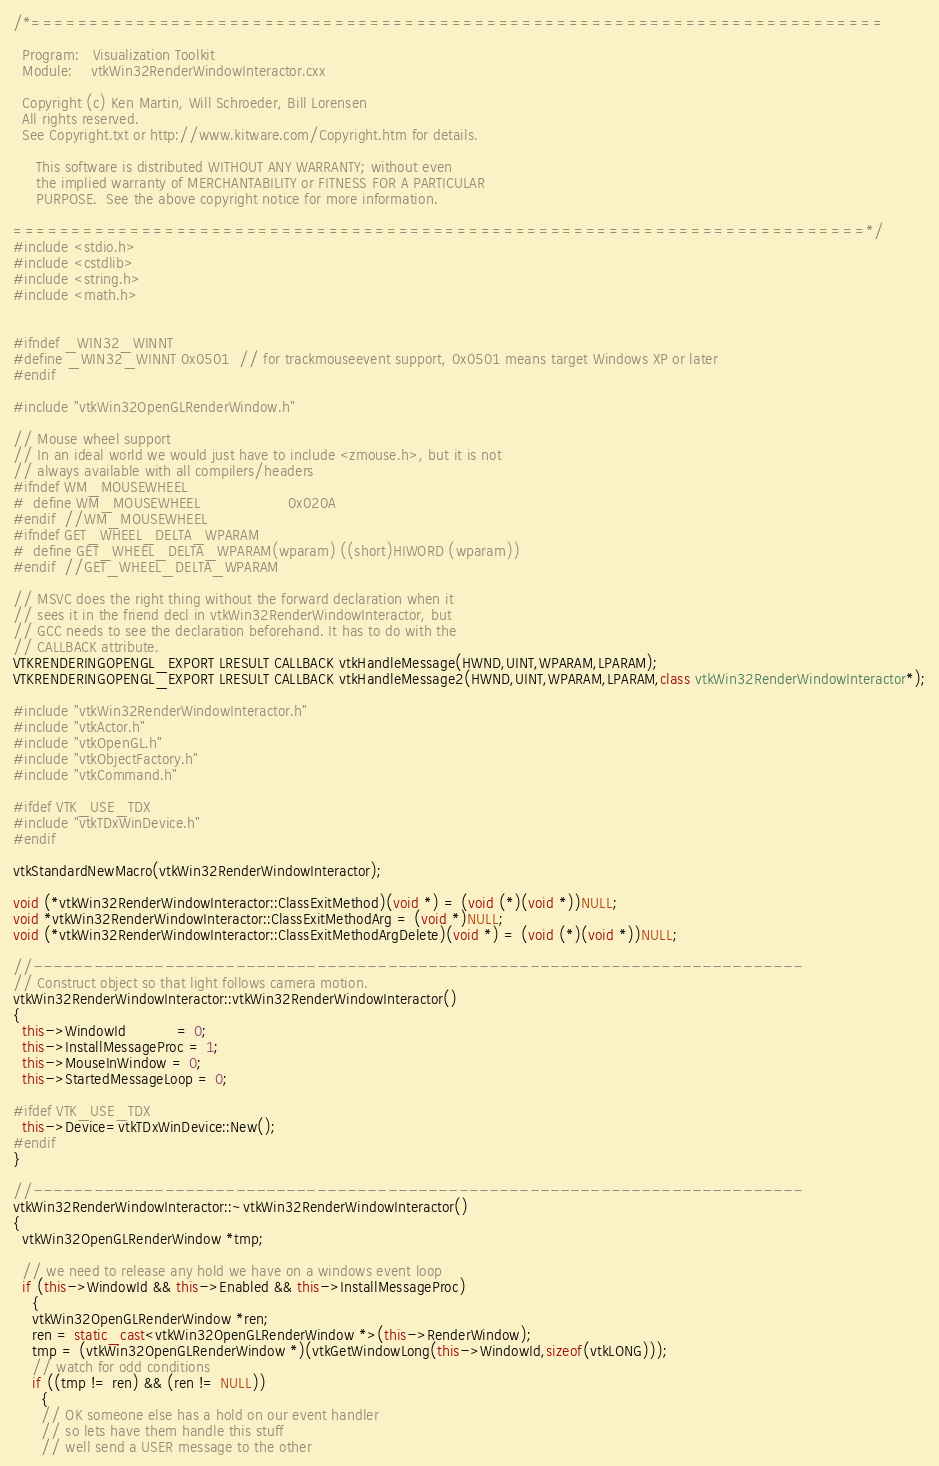Convert code to text. <code><loc_0><loc_0><loc_500><loc_500><_C++_>/*=========================================================================

  Program:   Visualization Toolkit
  Module:    vtkWin32RenderWindowInteractor.cxx

  Copyright (c) Ken Martin, Will Schroeder, Bill Lorensen
  All rights reserved.
  See Copyright.txt or http://www.kitware.com/Copyright.htm for details.

     This software is distributed WITHOUT ANY WARRANTY; without even
     the implied warranty of MERCHANTABILITY or FITNESS FOR A PARTICULAR
     PURPOSE.  See the above copyright notice for more information.

=========================================================================*/
#include <stdio.h>
#include <cstdlib>
#include <string.h>
#include <math.h>


#ifndef _WIN32_WINNT
#define _WIN32_WINNT 0x0501  // for trackmouseevent support, 0x0501 means target Windows XP or later
#endif

#include "vtkWin32OpenGLRenderWindow.h"

// Mouse wheel support
// In an ideal world we would just have to include <zmouse.h>, but it is not
// always available with all compilers/headers
#ifndef WM_MOUSEWHEEL
#  define WM_MOUSEWHEEL                   0x020A
#endif  //WM_MOUSEWHEEL
#ifndef GET_WHEEL_DELTA_WPARAM
#  define GET_WHEEL_DELTA_WPARAM(wparam) ((short)HIWORD (wparam))
#endif  //GET_WHEEL_DELTA_WPARAM

// MSVC does the right thing without the forward declaration when it
// sees it in the friend decl in vtkWin32RenderWindowInteractor, but
// GCC needs to see the declaration beforehand. It has to do with the
// CALLBACK attribute.
VTKRENDERINGOPENGL_EXPORT LRESULT CALLBACK vtkHandleMessage(HWND,UINT,WPARAM,LPARAM);
VTKRENDERINGOPENGL_EXPORT LRESULT CALLBACK vtkHandleMessage2(HWND,UINT,WPARAM,LPARAM,class vtkWin32RenderWindowInteractor*);

#include "vtkWin32RenderWindowInteractor.h"
#include "vtkActor.h"
#include "vtkOpenGL.h"
#include "vtkObjectFactory.h"
#include "vtkCommand.h"

#ifdef VTK_USE_TDX
#include "vtkTDxWinDevice.h"
#endif

vtkStandardNewMacro(vtkWin32RenderWindowInteractor);

void (*vtkWin32RenderWindowInteractor::ClassExitMethod)(void *) = (void (*)(void *))NULL;
void *vtkWin32RenderWindowInteractor::ClassExitMethodArg = (void *)NULL;
void (*vtkWin32RenderWindowInteractor::ClassExitMethodArgDelete)(void *) = (void (*)(void *))NULL;

//----------------------------------------------------------------------------
// Construct object so that light follows camera motion.
vtkWin32RenderWindowInteractor::vtkWin32RenderWindowInteractor()
{
  this->WindowId           = 0;
  this->InstallMessageProc = 1;
  this->MouseInWindow = 0;
  this->StartedMessageLoop = 0;

#ifdef VTK_USE_TDX
  this->Device=vtkTDxWinDevice::New();
#endif
}

//----------------------------------------------------------------------------
vtkWin32RenderWindowInteractor::~vtkWin32RenderWindowInteractor()
{
  vtkWin32OpenGLRenderWindow *tmp;

  // we need to release any hold we have on a windows event loop
  if (this->WindowId && this->Enabled && this->InstallMessageProc)
    {
    vtkWin32OpenGLRenderWindow *ren;
    ren = static_cast<vtkWin32OpenGLRenderWindow *>(this->RenderWindow);
    tmp = (vtkWin32OpenGLRenderWindow *)(vtkGetWindowLong(this->WindowId,sizeof(vtkLONG)));
    // watch for odd conditions
    if ((tmp != ren) && (ren != NULL))
      {
      // OK someone else has a hold on our event handler
      // so lets have them handle this stuff
      // well send a USER message to the other</code> 